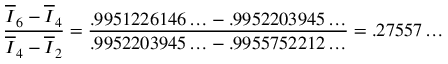Convert formula to latex. <formula><loc_0><loc_0><loc_500><loc_500>\frac { \overline { I } _ { 6 } - \overline { I } _ { 4 } } { \overline { I } _ { 4 } - \overline { I } _ { 2 } } = { \frac { . 9 9 5 1 2 2 6 1 4 6 \dots - . 9 9 5 2 2 0 3 9 4 5 \dots } { . 9 9 5 2 2 0 3 9 4 5 \dots - . 9 9 5 5 7 5 2 2 1 2 \dots } } = . 2 7 5 5 7 \dots</formula> 